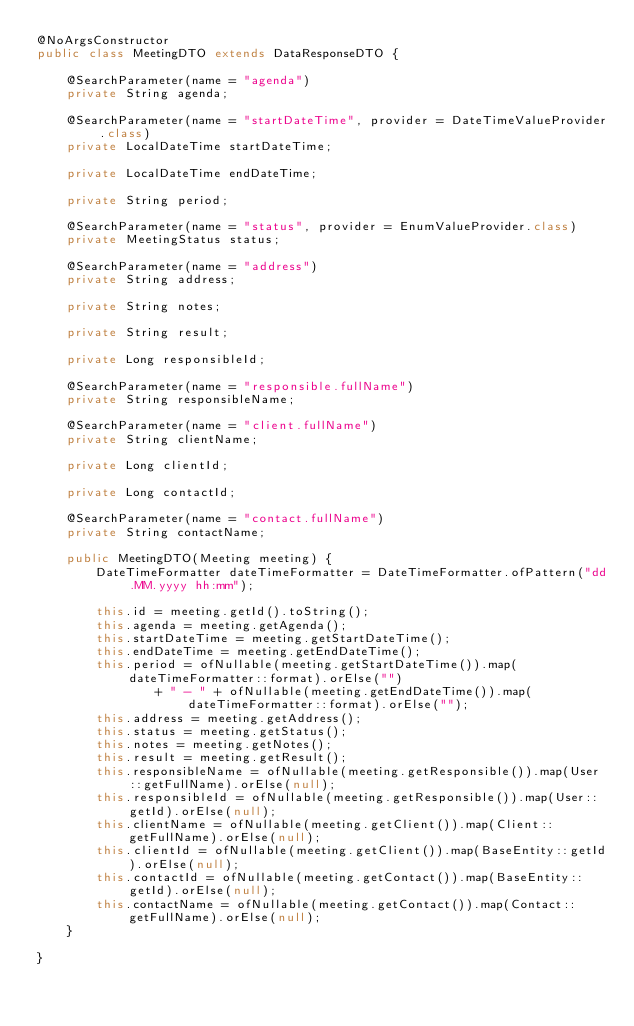Convert code to text. <code><loc_0><loc_0><loc_500><loc_500><_Java_>@NoArgsConstructor
public class MeetingDTO extends DataResponseDTO {

	@SearchParameter(name = "agenda")
	private String agenda;

	@SearchParameter(name = "startDateTime", provider = DateTimeValueProvider.class)
	private LocalDateTime startDateTime;

	private LocalDateTime endDateTime;

	private String period;

	@SearchParameter(name = "status", provider = EnumValueProvider.class)
	private MeetingStatus status;

	@SearchParameter(name = "address")
	private String address;

	private String notes;

	private String result;

	private Long responsibleId;

	@SearchParameter(name = "responsible.fullName")
	private String responsibleName;

	@SearchParameter(name = "client.fullName")
	private String clientName;

	private Long clientId;

	private Long contactId;

	@SearchParameter(name = "contact.fullName")
	private String contactName;

	public MeetingDTO(Meeting meeting) {
		DateTimeFormatter dateTimeFormatter = DateTimeFormatter.ofPattern("dd.MM.yyyy hh:mm");

		this.id = meeting.getId().toString();
		this.agenda = meeting.getAgenda();
		this.startDateTime = meeting.getStartDateTime();
		this.endDateTime = meeting.getEndDateTime();
		this.period = ofNullable(meeting.getStartDateTime()).map(dateTimeFormatter::format).orElse("")
				+ " - " + ofNullable(meeting.getEndDateTime()).map(dateTimeFormatter::format).orElse("");
		this.address = meeting.getAddress();
		this.status = meeting.getStatus();
		this.notes = meeting.getNotes();
		this.result = meeting.getResult();
		this.responsibleName = ofNullable(meeting.getResponsible()).map(User::getFullName).orElse(null);
		this.responsibleId = ofNullable(meeting.getResponsible()).map(User::getId).orElse(null);
		this.clientName = ofNullable(meeting.getClient()).map(Client::getFullName).orElse(null);
		this.clientId = ofNullable(meeting.getClient()).map(BaseEntity::getId).orElse(null);
		this.contactId = ofNullable(meeting.getContact()).map(BaseEntity::getId).orElse(null);
		this.contactName = ofNullable(meeting.getContact()).map(Contact::getFullName).orElse(null);
	}

}
</code> 